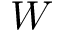<formula> <loc_0><loc_0><loc_500><loc_500>W</formula> 